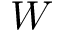<formula> <loc_0><loc_0><loc_500><loc_500>W</formula> 